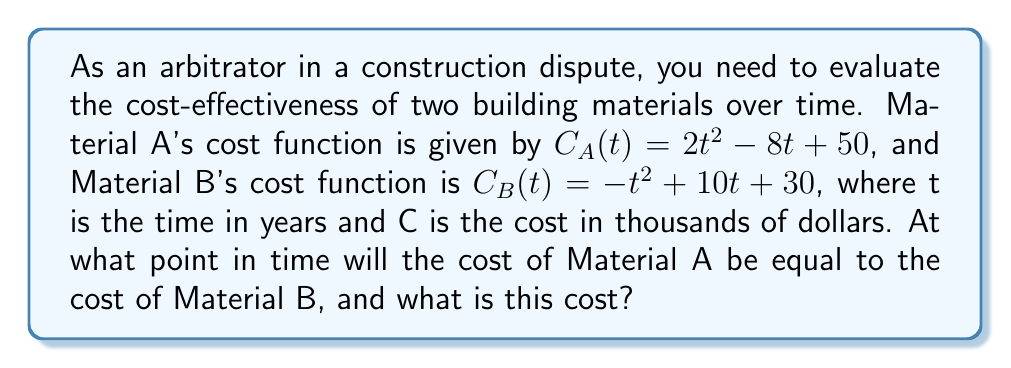Give your solution to this math problem. To solve this problem, we need to follow these steps:

1) Set the two cost functions equal to each other:
   $$2t^2 - 8t + 50 = -t^2 + 10t + 30$$

2) Rearrange the equation to standard form:
   $$2t^2 - 8t + 50 = -t^2 + 10t + 30$$
   $$2t^2 + t^2 - 8t - 10t + 50 - 30 = 0$$
   $$3t^2 - 18t + 20 = 0$$

3) This is a quadratic equation. We can solve it using the quadratic formula:
   $$t = \frac{-b \pm \sqrt{b^2 - 4ac}}{2a}$$
   where $a = 3$, $b = -18$, and $c = 20$

4) Substituting these values:
   $$t = \frac{18 \pm \sqrt{(-18)^2 - 4(3)(20)}}{2(3)}$$
   $$t = \frac{18 \pm \sqrt{324 - 240}}{6}$$
   $$t = \frac{18 \pm \sqrt{84}}{6}$$
   $$t = \frac{18 \pm 9.17}{6}$$

5) This gives us two solutions:
   $$t_1 = \frac{18 + 9.17}{6} \approx 4.53$$
   $$t_2 = \frac{18 - 9.17}{6} \approx 1.47$$

6) Since we're dealing with time, and the question asks for a single point, we'll use the positive solution: $t \approx 4.53$ years.

7) To find the cost at this time, we can substitute this value of t into either cost function:
   $$C_A(4.53) = 2(4.53)^2 - 8(4.53) + 50 \approx 59.54$$

Therefore, the costs will be equal after approximately 4.53 years, at a cost of about $59,540.
Answer: 4.53 years, $59,540 